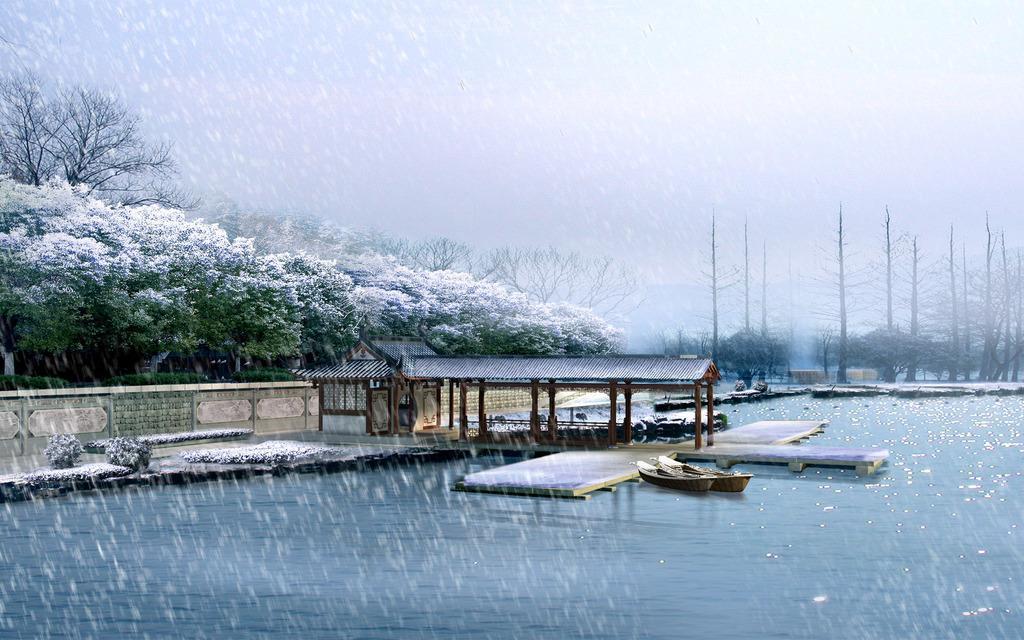Can you describe this image briefly? In this image we can see one small house near the lake, snowing over a lake, two small boats on the lake, some plants, some bushes, some big trees on the ground, one wall with text, some objects on the ground, some snow on the trees, bushes and plants. At the top there is the cloudy sky. 